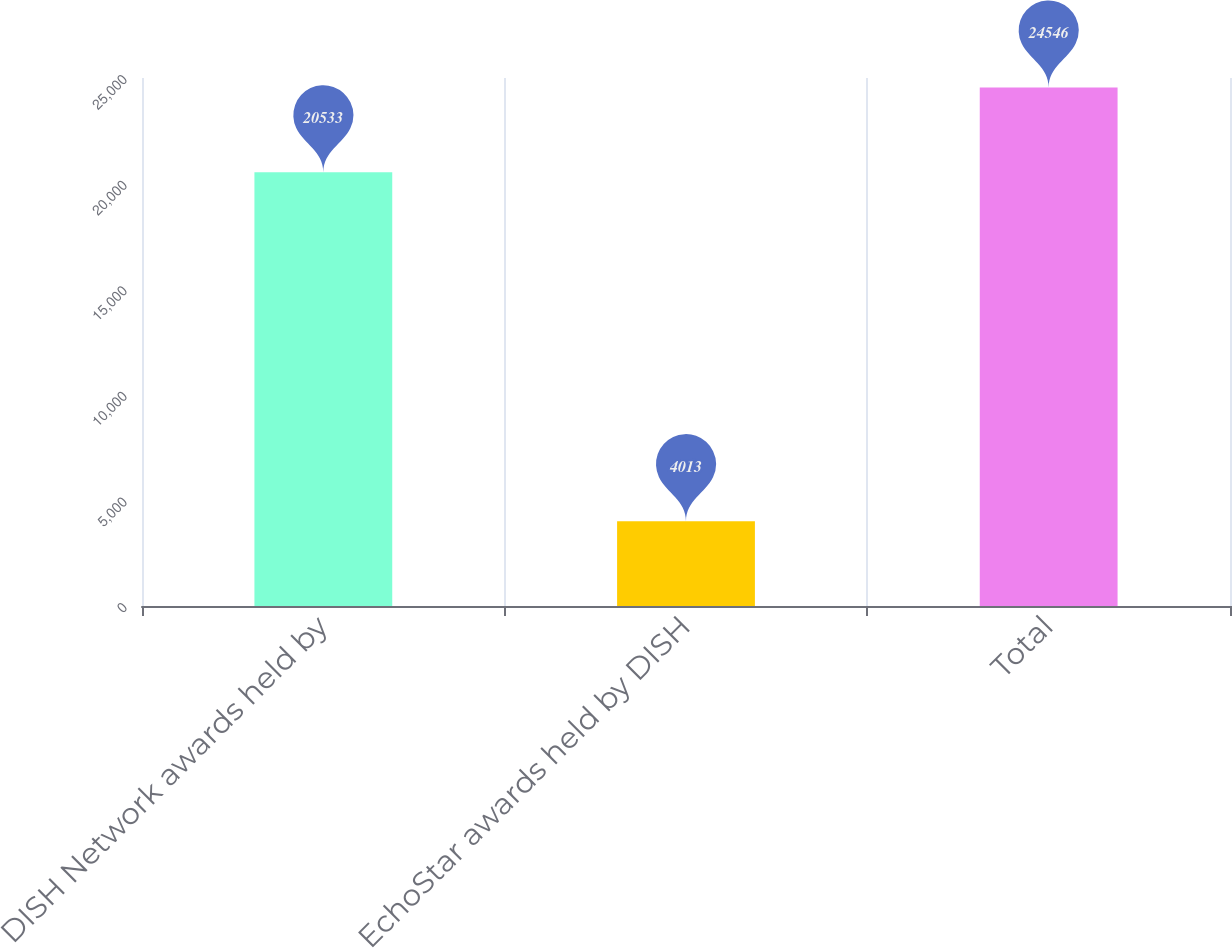<chart> <loc_0><loc_0><loc_500><loc_500><bar_chart><fcel>DISH Network awards held by<fcel>EchoStar awards held by DISH<fcel>Total<nl><fcel>20533<fcel>4013<fcel>24546<nl></chart> 